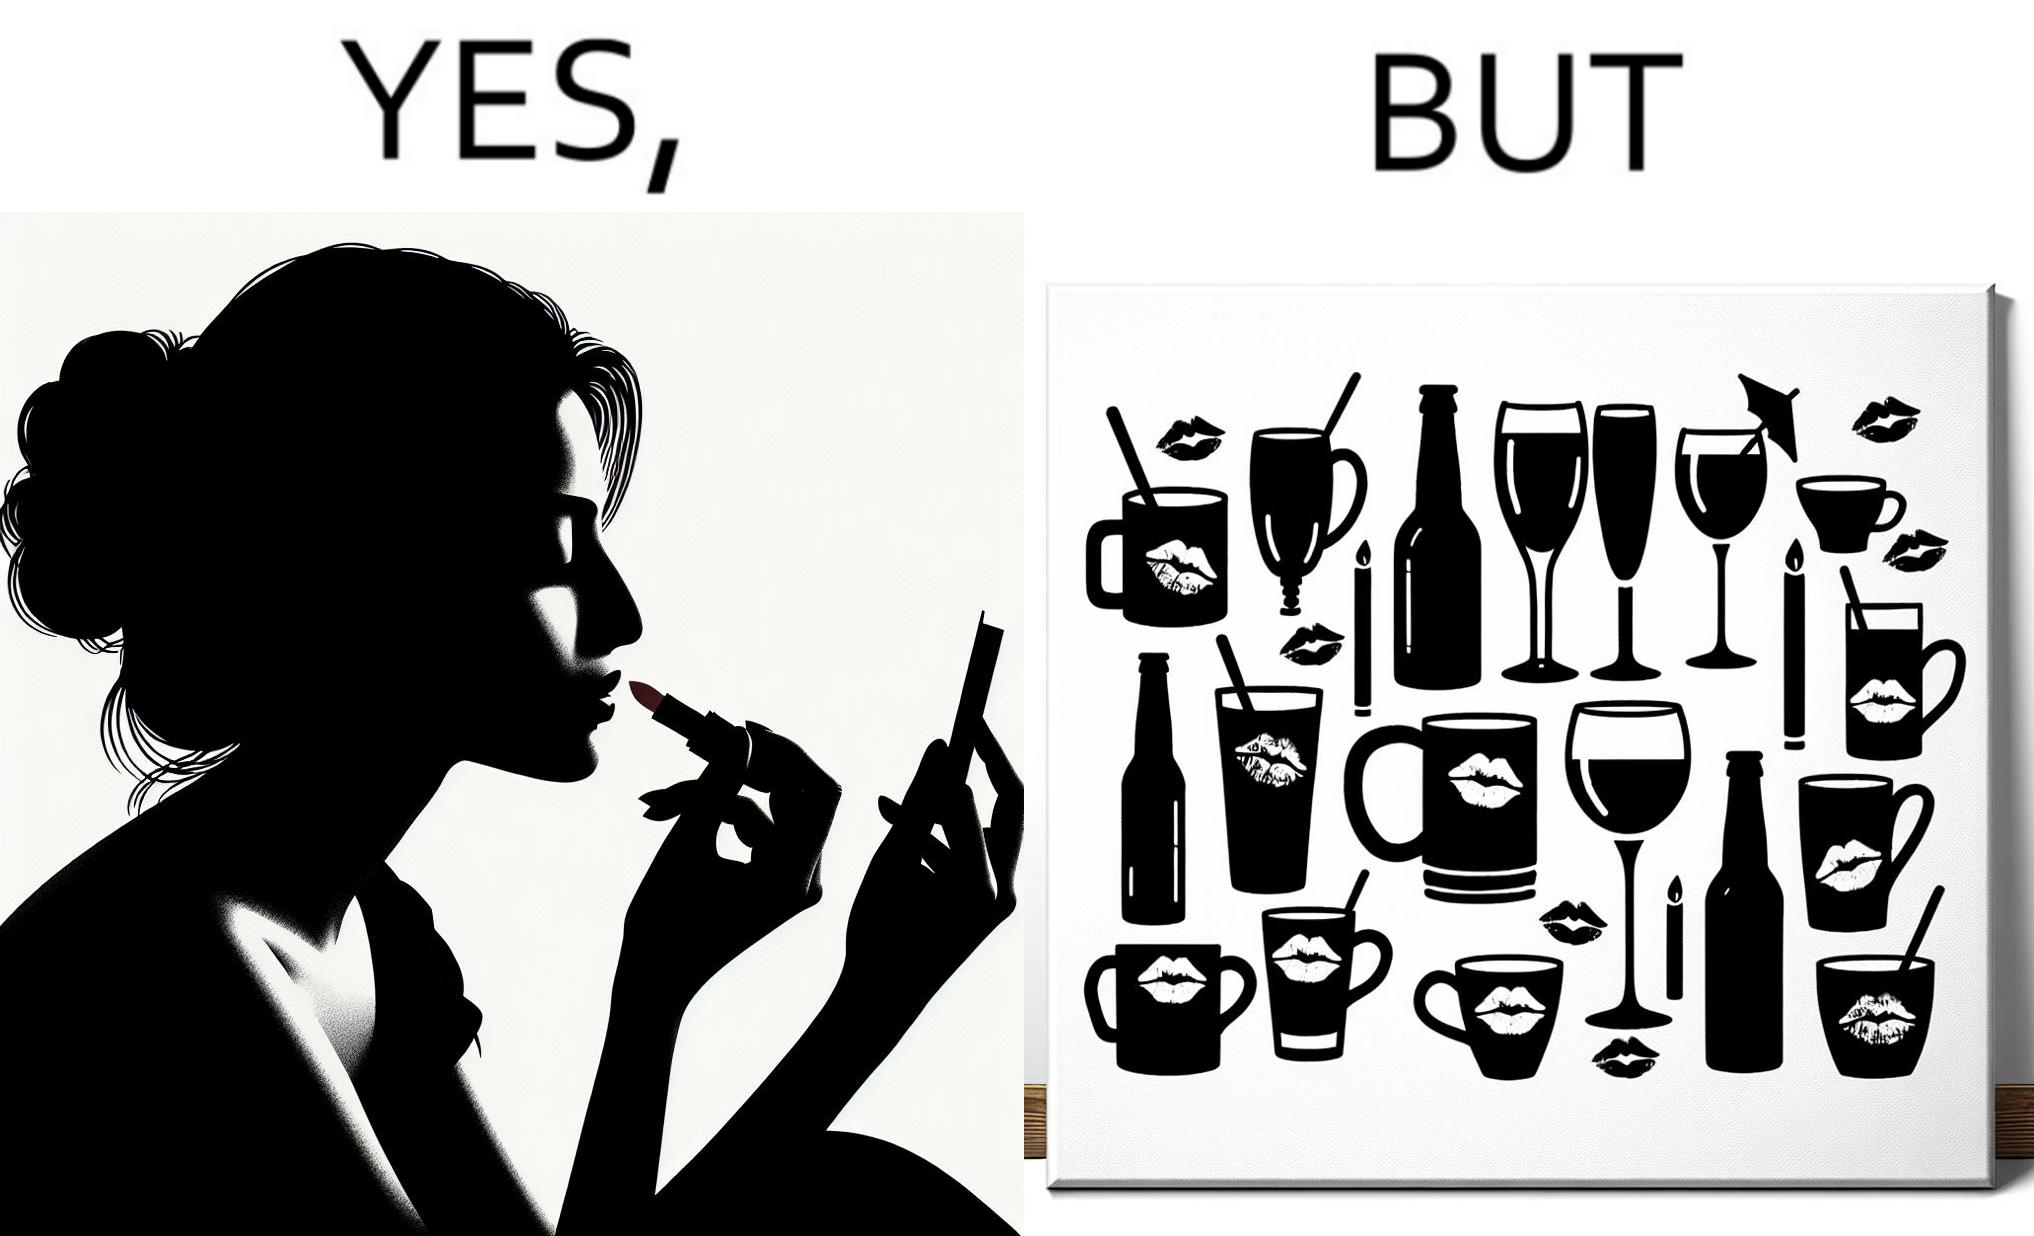Describe the content of this image. The image is ironic, because the left image suggest that a person applies lipsticks on their lips to make their lips look attractive or to keep them hydrated but on the contrary it gets sticked to the glasses or mugs and gets wasted 